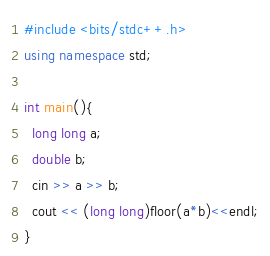Convert code to text. <code><loc_0><loc_0><loc_500><loc_500><_C++_>#include <bits/stdc++.h>
using namespace std;

int main(){
  long long a;
  double b;
  cin >> a >> b;
  cout << (long long)floor(a*b)<<endl;
}</code> 